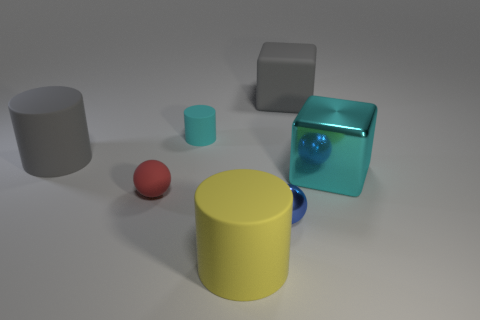Add 2 small rubber things. How many objects exist? 9 Subtract all red cubes. Subtract all red cylinders. How many cubes are left? 2 Subtract all blocks. How many objects are left? 5 Subtract all cyan matte objects. Subtract all cyan metallic objects. How many objects are left? 5 Add 6 big yellow cylinders. How many big yellow cylinders are left? 7 Add 5 tiny cylinders. How many tiny cylinders exist? 6 Subtract 0 green cubes. How many objects are left? 7 